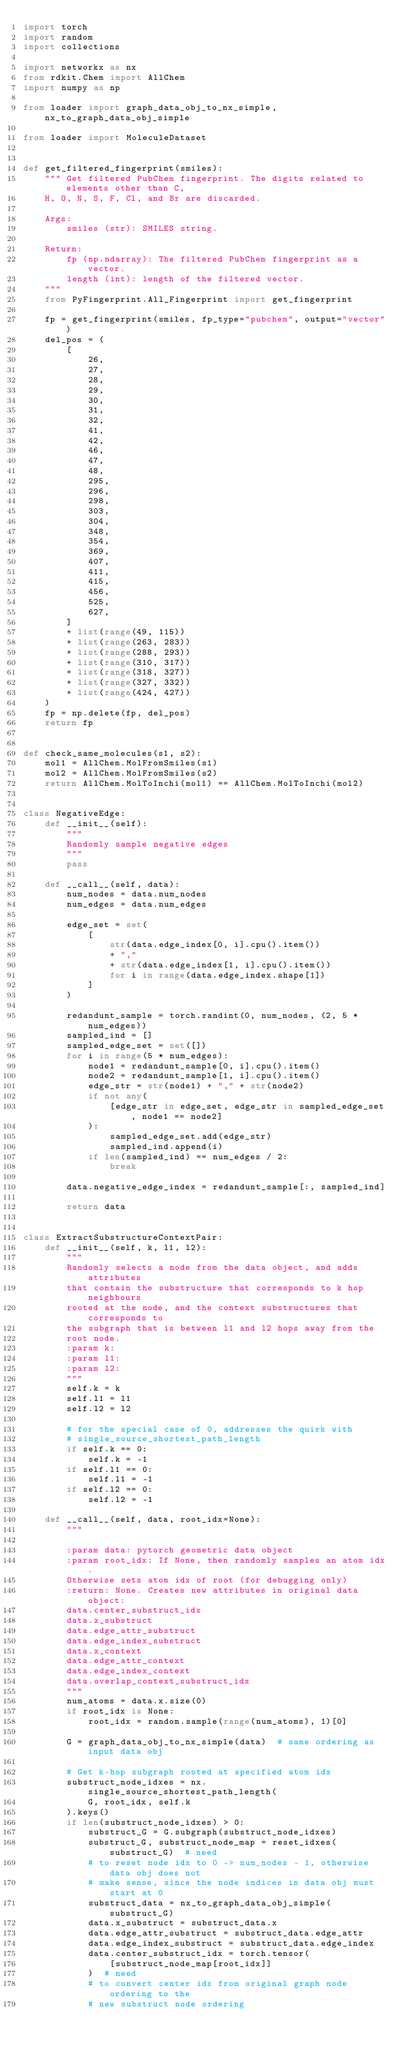<code> <loc_0><loc_0><loc_500><loc_500><_Python_>import torch
import random
import collections

import networkx as nx
from rdkit.Chem import AllChem
import numpy as np

from loader import graph_data_obj_to_nx_simple, nx_to_graph_data_obj_simple

from loader import MoleculeDataset


def get_filtered_fingerprint(smiles):
    """ Get filtered PubChem fingerprint. The digits related to elements other than C,
    H, O, N, S, F, Cl, and Br are discarded.

    Args:
        smiles (str): SMILES string.

    Return:
        fp (np.ndarray): The filtered PubChem fingerprint as a vector.
        length (int): length of the filtered vector.
    """
    from PyFingerprint.All_Fingerprint import get_fingerprint

    fp = get_fingerprint(smiles, fp_type="pubchem", output="vector")
    del_pos = (
        [
            26,
            27,
            28,
            29,
            30,
            31,
            32,
            41,
            42,
            46,
            47,
            48,
            295,
            296,
            298,
            303,
            304,
            348,
            354,
            369,
            407,
            411,
            415,
            456,
            525,
            627,
        ]
        + list(range(49, 115))
        + list(range(263, 283))
        + list(range(288, 293))
        + list(range(310, 317))
        + list(range(318, 327))
        + list(range(327, 332))
        + list(range(424, 427))
    )
    fp = np.delete(fp, del_pos)
    return fp


def check_same_molecules(s1, s2):
    mol1 = AllChem.MolFromSmiles(s1)
    mol2 = AllChem.MolFromSmiles(s2)
    return AllChem.MolToInchi(mol1) == AllChem.MolToInchi(mol2)


class NegativeEdge:
    def __init__(self):
        """
        Randomly sample negative edges
        """
        pass

    def __call__(self, data):
        num_nodes = data.num_nodes
        num_edges = data.num_edges

        edge_set = set(
            [
                str(data.edge_index[0, i].cpu().item())
                + ","
                + str(data.edge_index[1, i].cpu().item())
                for i in range(data.edge_index.shape[1])
            ]
        )

        redandunt_sample = torch.randint(0, num_nodes, (2, 5 * num_edges))
        sampled_ind = []
        sampled_edge_set = set([])
        for i in range(5 * num_edges):
            node1 = redandunt_sample[0, i].cpu().item()
            node2 = redandunt_sample[1, i].cpu().item()
            edge_str = str(node1) + "," + str(node2)
            if not any(
                [edge_str in edge_set, edge_str in sampled_edge_set, node1 == node2]
            ):
                sampled_edge_set.add(edge_str)
                sampled_ind.append(i)
            if len(sampled_ind) == num_edges / 2:
                break

        data.negative_edge_index = redandunt_sample[:, sampled_ind]

        return data


class ExtractSubstructureContextPair:
    def __init__(self, k, l1, l2):
        """
        Randomly selects a node from the data object, and adds attributes
        that contain the substructure that corresponds to k hop neighbours
        rooted at the node, and the context substructures that corresponds to
        the subgraph that is between l1 and l2 hops away from the
        root node.
        :param k:
        :param l1:
        :param l2:
        """
        self.k = k
        self.l1 = l1
        self.l2 = l2

        # for the special case of 0, addresses the quirk with
        # single_source_shortest_path_length
        if self.k == 0:
            self.k = -1
        if self.l1 == 0:
            self.l1 = -1
        if self.l2 == 0:
            self.l2 = -1

    def __call__(self, data, root_idx=None):
        """

        :param data: pytorch geometric data object
        :param root_idx: If None, then randomly samples an atom idx.
        Otherwise sets atom idx of root (for debugging only)
        :return: None. Creates new attributes in original data object:
        data.center_substruct_idx
        data.x_substruct
        data.edge_attr_substruct
        data.edge_index_substruct
        data.x_context
        data.edge_attr_context
        data.edge_index_context
        data.overlap_context_substruct_idx
        """
        num_atoms = data.x.size(0)
        if root_idx is None:
            root_idx = random.sample(range(num_atoms), 1)[0]

        G = graph_data_obj_to_nx_simple(data)  # same ordering as input data obj

        # Get k-hop subgraph rooted at specified atom idx
        substruct_node_idxes = nx.single_source_shortest_path_length(
            G, root_idx, self.k
        ).keys()
        if len(substruct_node_idxes) > 0:
            substruct_G = G.subgraph(substruct_node_idxes)
            substruct_G, substruct_node_map = reset_idxes(substruct_G)  # need
            # to reset node idx to 0 -> num_nodes - 1, otherwise data obj does not
            # make sense, since the node indices in data obj must start at 0
            substruct_data = nx_to_graph_data_obj_simple(substruct_G)
            data.x_substruct = substruct_data.x
            data.edge_attr_substruct = substruct_data.edge_attr
            data.edge_index_substruct = substruct_data.edge_index
            data.center_substruct_idx = torch.tensor(
                [substruct_node_map[root_idx]]
            )  # need
            # to convert center idx from original graph node ordering to the
            # new substruct node ordering
</code> 